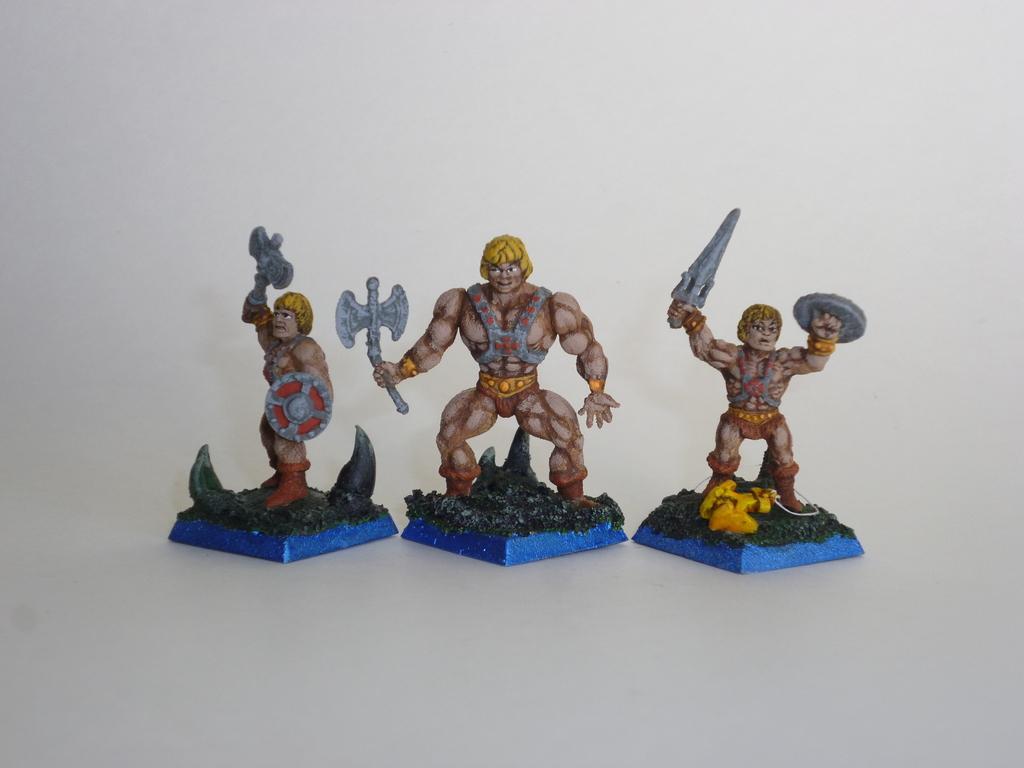How would you summarize this image in a sentence or two? In this image we can see sculptures. 